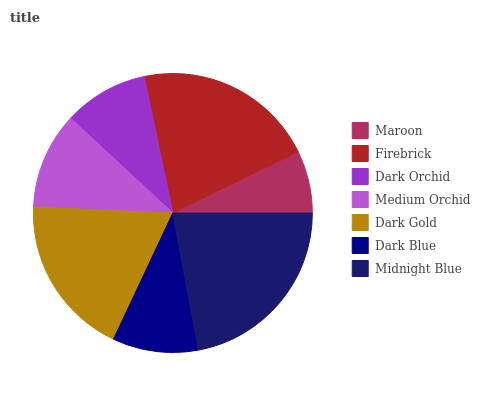Is Maroon the minimum?
Answer yes or no. Yes. Is Midnight Blue the maximum?
Answer yes or no. Yes. Is Firebrick the minimum?
Answer yes or no. No. Is Firebrick the maximum?
Answer yes or no. No. Is Firebrick greater than Maroon?
Answer yes or no. Yes. Is Maroon less than Firebrick?
Answer yes or no. Yes. Is Maroon greater than Firebrick?
Answer yes or no. No. Is Firebrick less than Maroon?
Answer yes or no. No. Is Medium Orchid the high median?
Answer yes or no. Yes. Is Medium Orchid the low median?
Answer yes or no. Yes. Is Firebrick the high median?
Answer yes or no. No. Is Midnight Blue the low median?
Answer yes or no. No. 